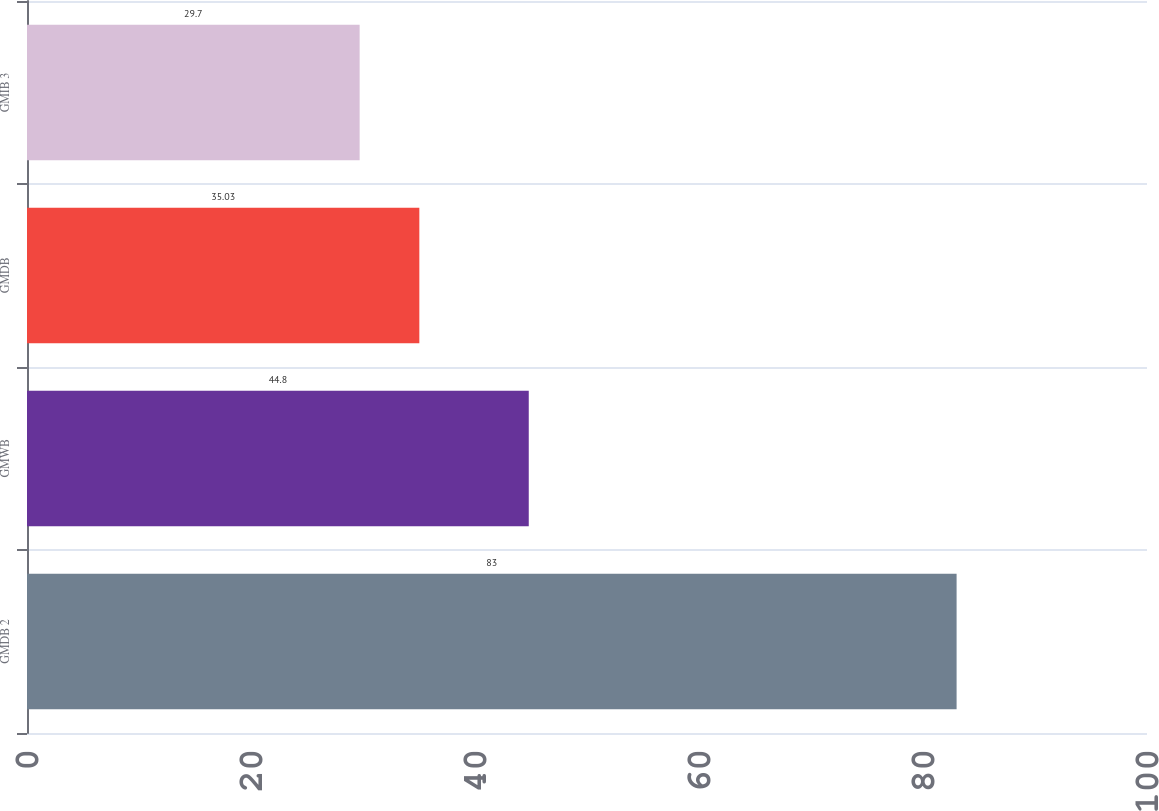Convert chart. <chart><loc_0><loc_0><loc_500><loc_500><bar_chart><fcel>GMDB 2<fcel>GMWB<fcel>GMDB<fcel>GMIB 3<nl><fcel>83<fcel>44.8<fcel>35.03<fcel>29.7<nl></chart> 